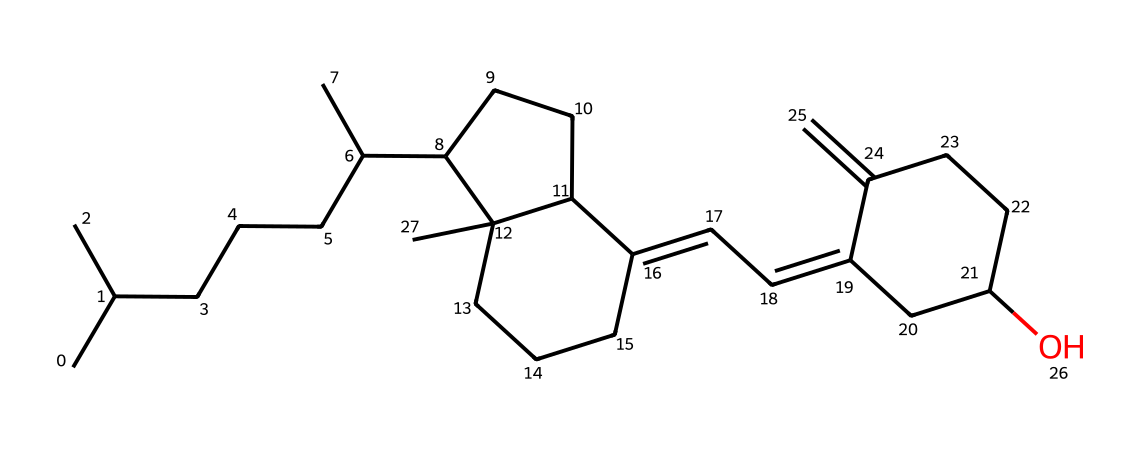What is the molecular formula of this vitamin? To find the molecular formula, we need to count the number of carbon (C), hydrogen (H), and oxygen (O) atoms in the structure. By analyzing the SMILES notation, the counts yield 27 carbons, 46 hydrogens, and 1 oxygen. Thus, the molecular formula is C27H46O.
Answer: C27H46O How many rings are present in the structure? By examining the chemical structure, we identify rings based on the closed loops formed by the carbon atoms. There are three distinct cyclic structures, indicating the presence of three rings.
Answer: 3 Is this vitamin fat-soluble or water-soluble? Vitamins can generally be classified as fat-soluble or water-soluble based on their chemical properties. Given the structure's long hydrocarbon chain and few polar groups (only one oxygen), it suggests that this vitamin is predominantly fat-soluble.
Answer: fat-soluble What type of vitamin is represented by this structure? By recognizing the specific molecular features and structure associated with vitamins, particularly those involved in bone health, it can be identified as a vitamin D variant. This can be concluded from the specific steroid-like structure which is characteristic of Vitamin D.
Answer: vitamin D What is the importance of this vitamin for soldiers' health? Vitamin D is crucial for the regulation of calcium and phosphate in the body, which are essential for maintaining strong bones. This is particularly important for soldiers who endure physical stress during campaigns and need strong skeletal support.
Answer: bone health 